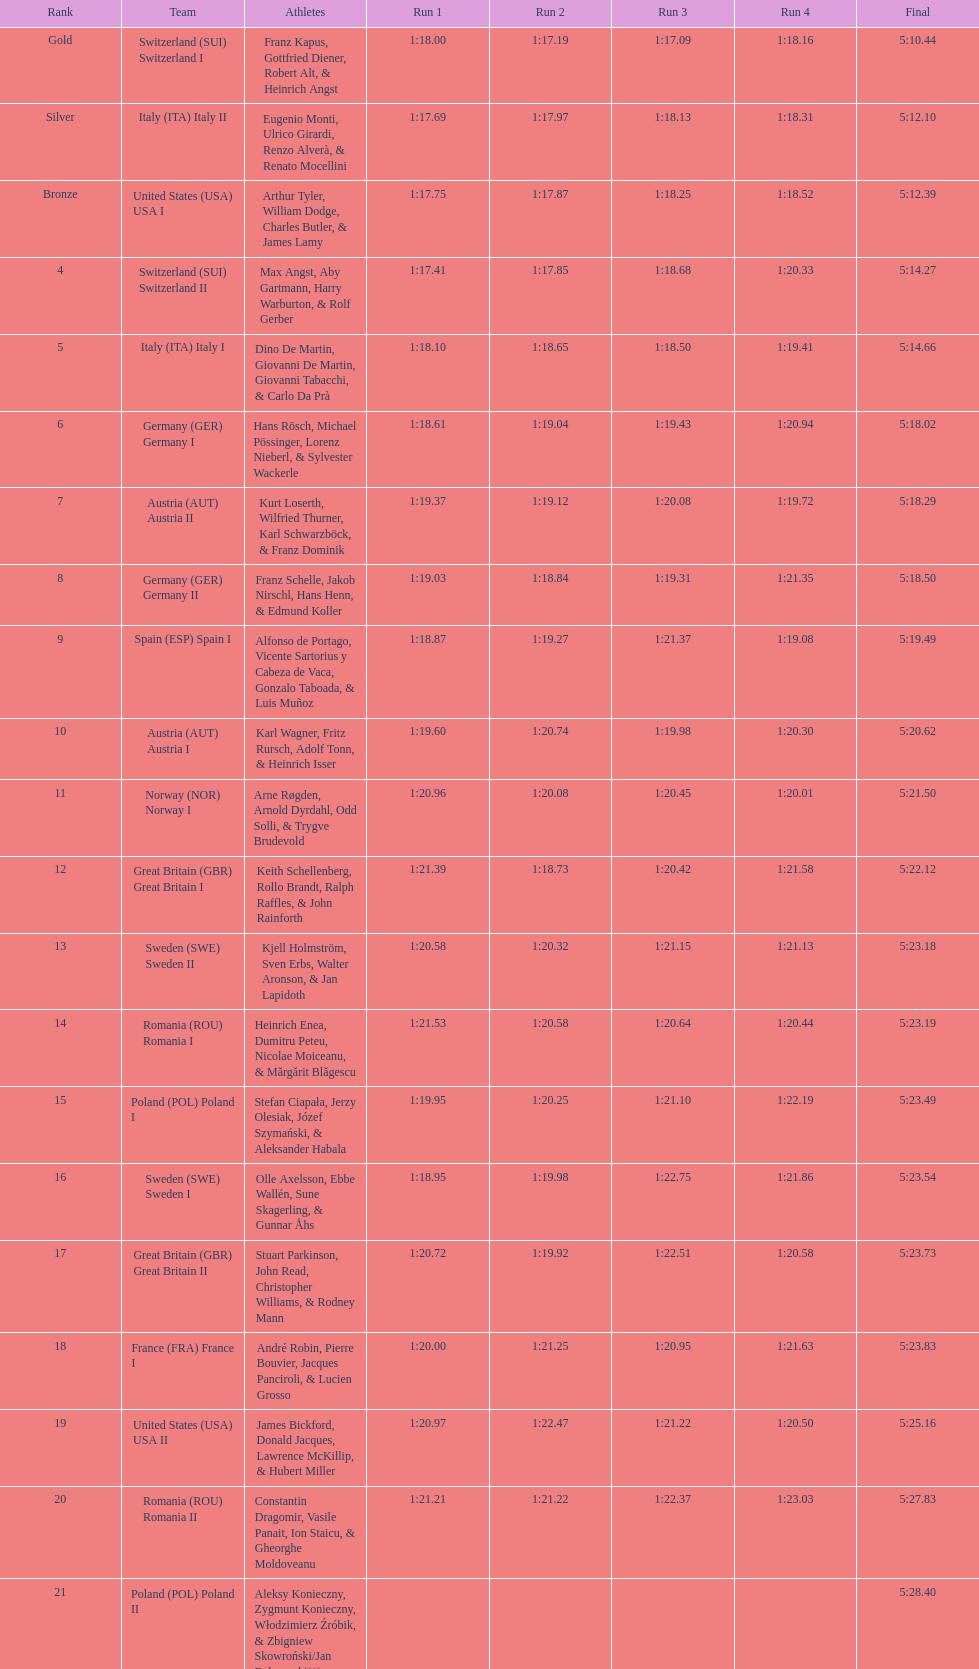How many squads did germany possess? 2. 